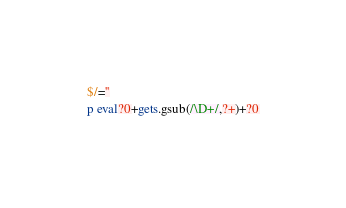Convert code to text. <code><loc_0><loc_0><loc_500><loc_500><_Ruby_>$/=''
p eval?0+gets.gsub(/\D+/,?+)+?0</code> 